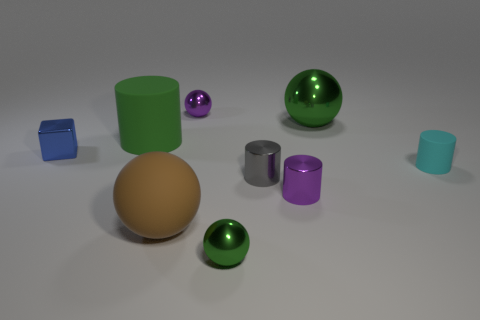There is a green metal ball that is behind the sphere that is on the left side of the purple ball; what is its size?
Ensure brevity in your answer.  Large. Is there a large brown metallic thing?
Offer a very short reply. No. There is a metal sphere that is on the right side of the gray metal cylinder; how many small purple shiny cylinders are left of it?
Your answer should be compact. 1. What shape is the big matte thing that is left of the large brown matte sphere?
Offer a terse response. Cylinder. There is a large sphere in front of the small cylinder right of the large sphere that is right of the small purple ball; what is its material?
Your answer should be very brief. Rubber. How many other objects are the same size as the gray metal cylinder?
Your answer should be compact. 5. What is the material of the green thing that is the same shape as the gray shiny thing?
Offer a very short reply. Rubber. The block is what color?
Your answer should be compact. Blue. There is a ball that is to the left of the purple metallic thing that is behind the cyan rubber cylinder; what color is it?
Offer a very short reply. Brown. There is a small block; is its color the same as the tiny cylinder to the right of the large green shiny object?
Your answer should be very brief. No. 